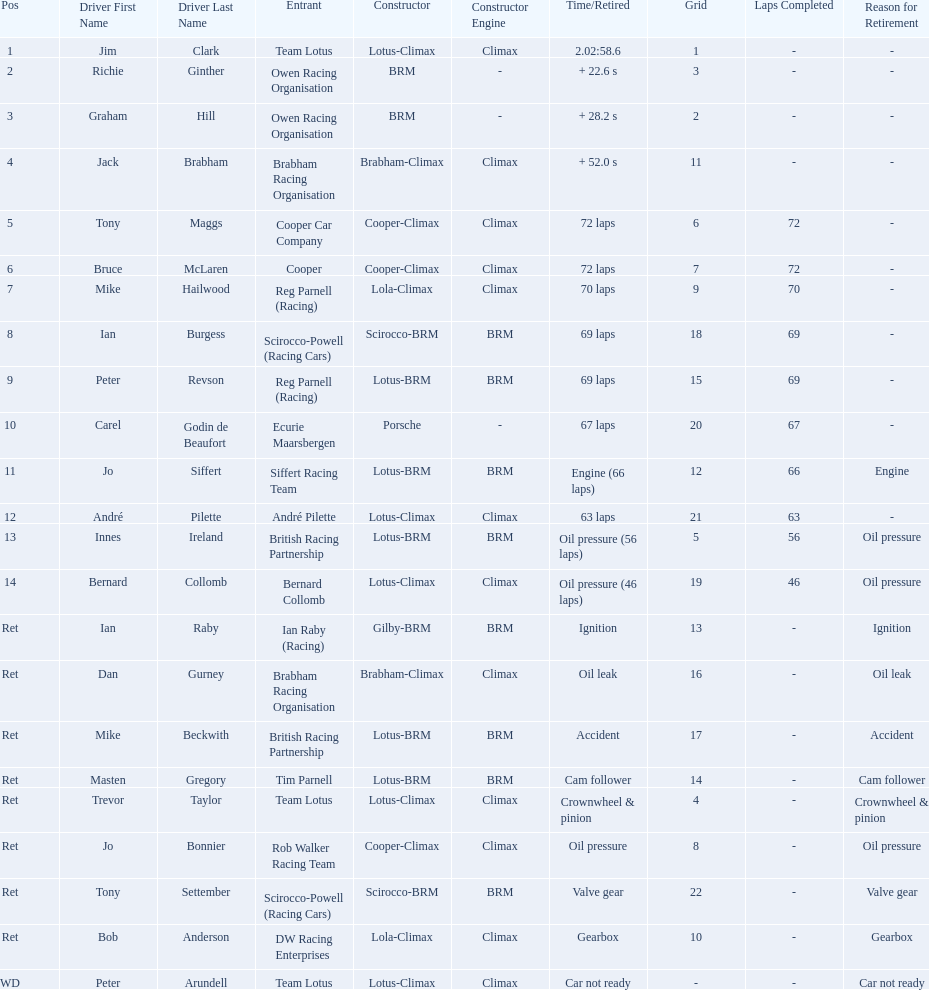Who are all the drivers? Jim Clark, Richie Ginther, Graham Hill, Jack Brabham, Tony Maggs, Bruce McLaren, Mike Hailwood, Ian Burgess, Peter Revson, Carel Godin de Beaufort, Jo Siffert, André Pilette, Innes Ireland, Bernard Collomb, Ian Raby, Dan Gurney, Mike Beckwith, Masten Gregory, Trevor Taylor, Jo Bonnier, Tony Settember, Bob Anderson, Peter Arundell. Which drove a cooper-climax? Tony Maggs, Bruce McLaren, Jo Bonnier. Of those, who was the top finisher? Tony Maggs. 